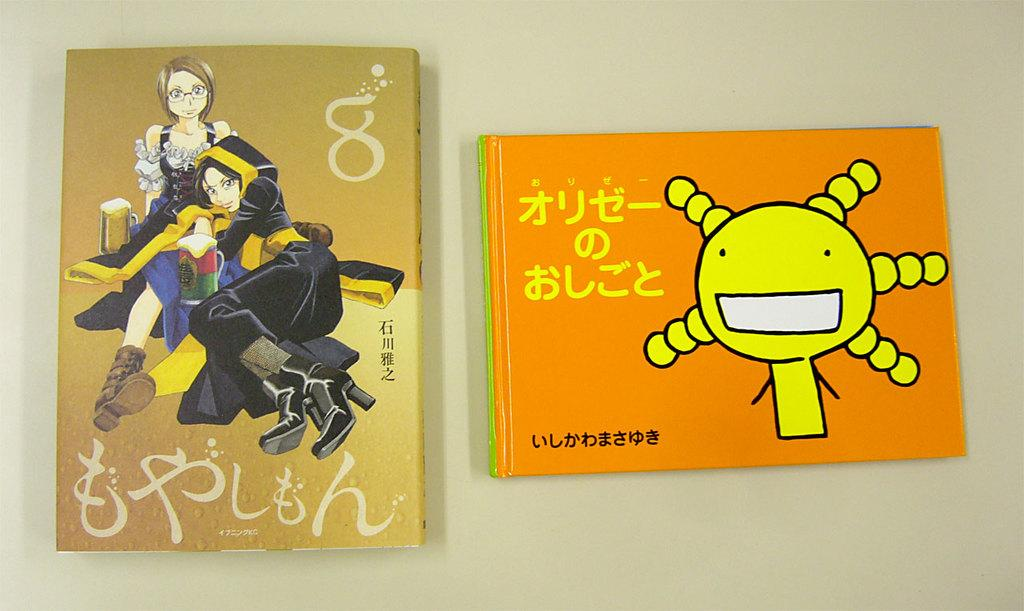What objects are on the table in the image? There are books on the table in the image. What type of bird can be seen sitting on the books in the image? There are no birds present in the image, so it is not possible to determine what type of bird might be sitting on the books. 